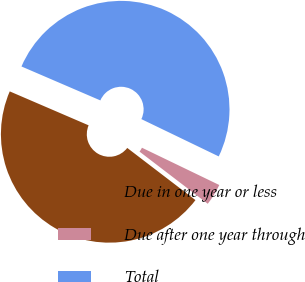Convert chart. <chart><loc_0><loc_0><loc_500><loc_500><pie_chart><fcel>Due in one year or less<fcel>Due after one year through<fcel>Total<nl><fcel>46.08%<fcel>3.24%<fcel>50.69%<nl></chart> 